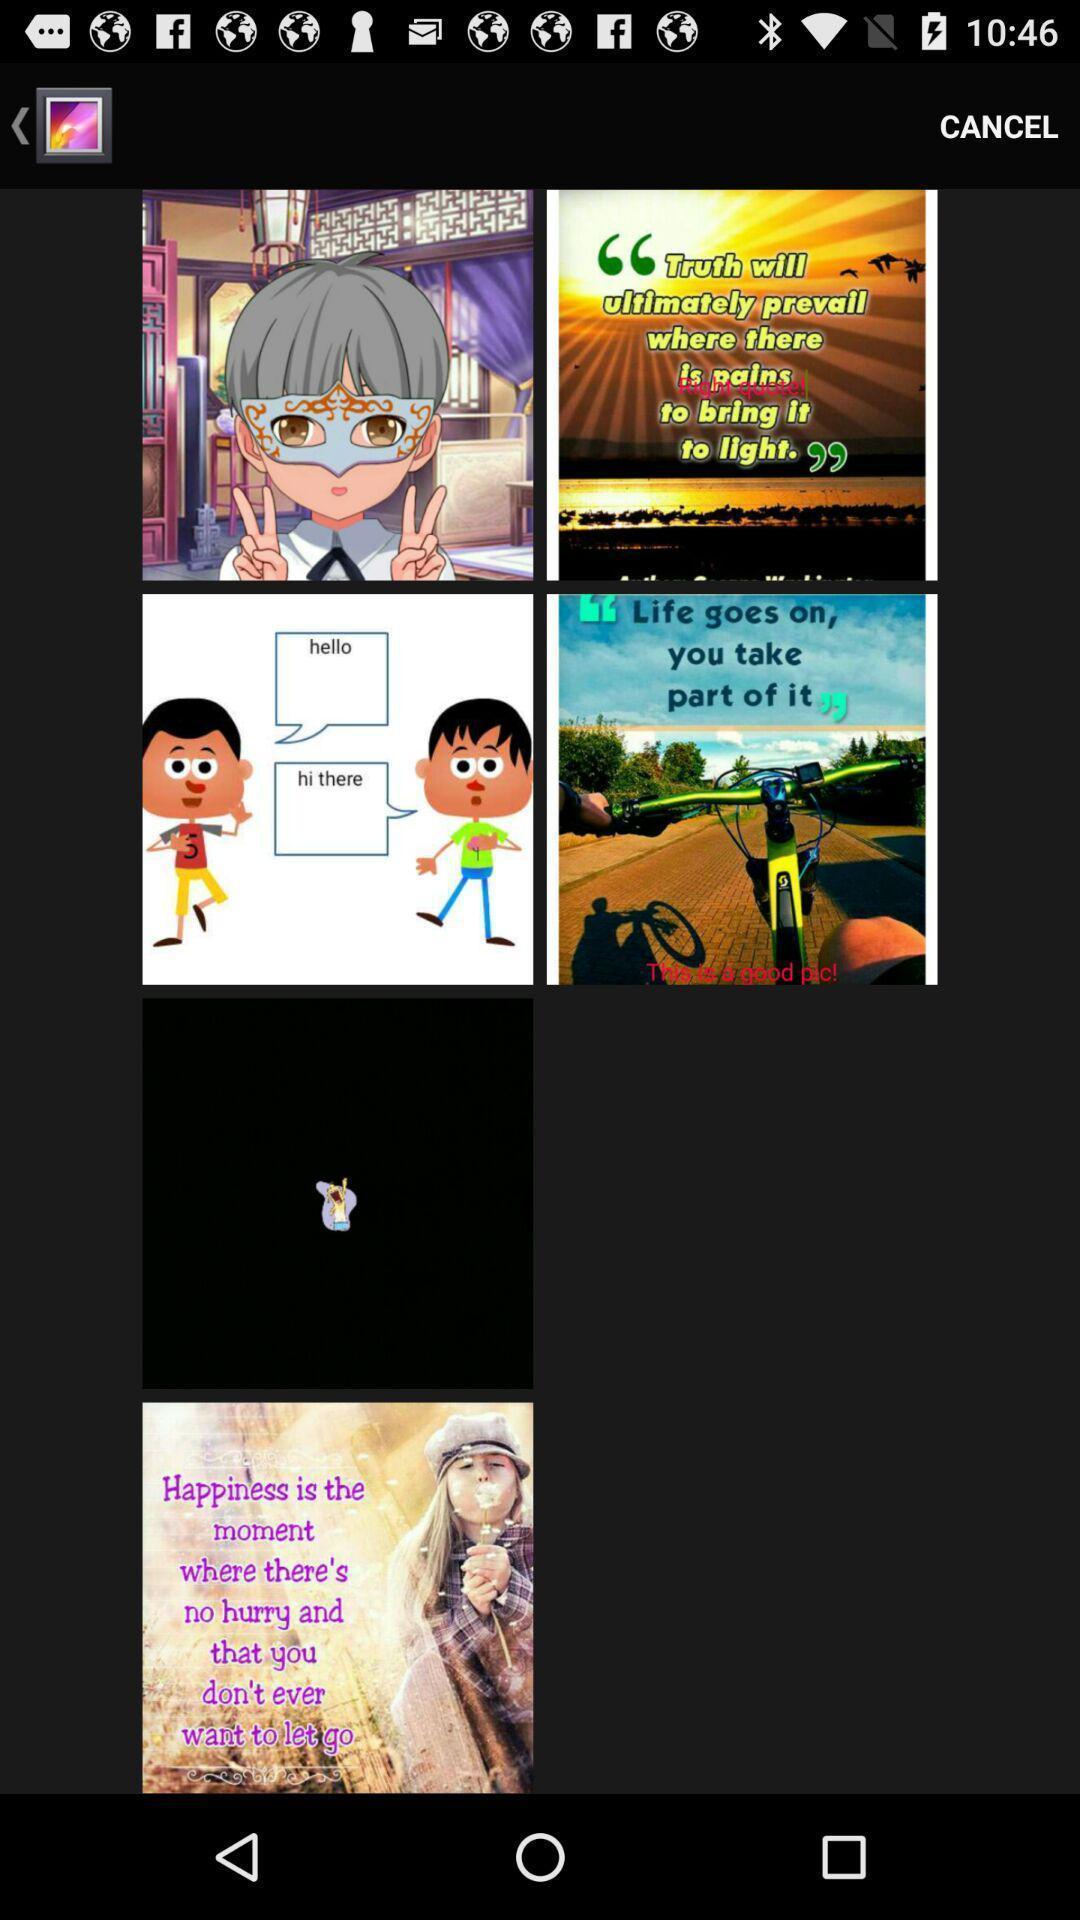What is the overall content of this screenshot? Page shows different pictures and some text on the pictures. 